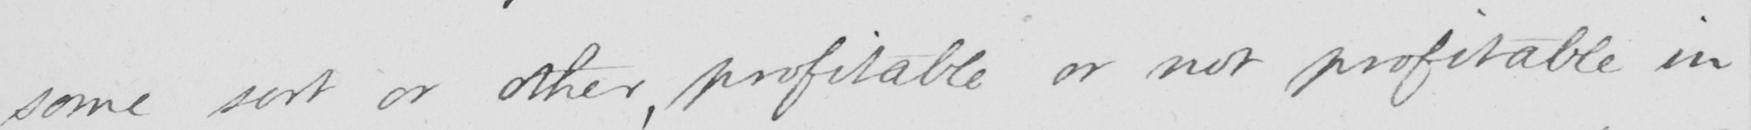What is written in this line of handwriting? some sort or other , profitable or not profitable in 